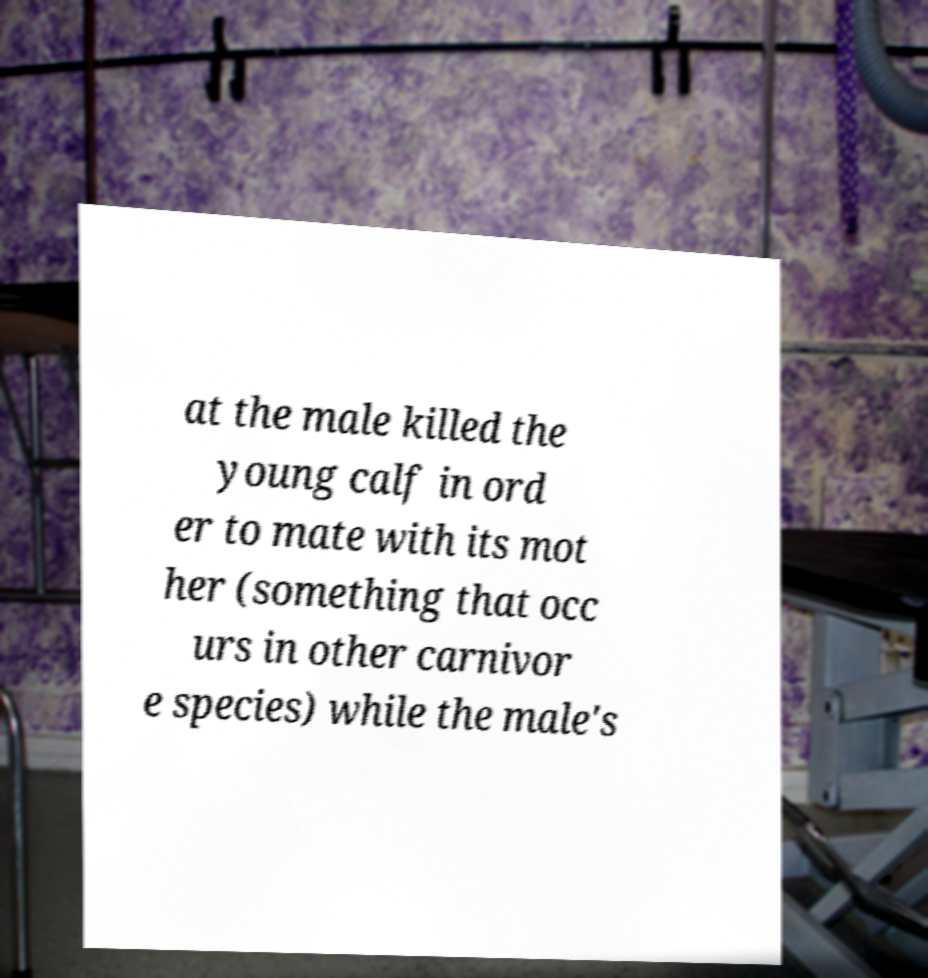Can you accurately transcribe the text from the provided image for me? at the male killed the young calf in ord er to mate with its mot her (something that occ urs in other carnivor e species) while the male's 